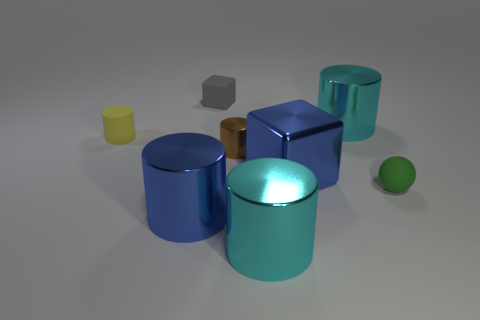Subtract all cyan cylinders. How many were subtracted if there are1cyan cylinders left? 1 Subtract 1 cylinders. How many cylinders are left? 4 Subtract all brown cylinders. How many cylinders are left? 4 Subtract all big blue cylinders. How many cylinders are left? 4 Subtract all purple cylinders. Subtract all red balls. How many cylinders are left? 5 Add 2 tiny brown metallic cubes. How many objects exist? 10 Subtract all cylinders. How many objects are left? 3 Subtract 0 red cubes. How many objects are left? 8 Subtract all cyan things. Subtract all small gray rubber blocks. How many objects are left? 5 Add 2 big cyan objects. How many big cyan objects are left? 4 